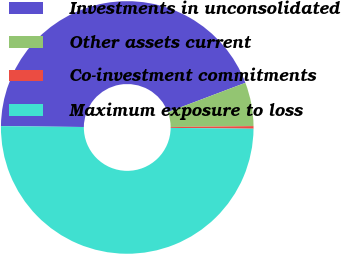Convert chart to OTSL. <chart><loc_0><loc_0><loc_500><loc_500><pie_chart><fcel>Investments in unconsolidated<fcel>Other assets current<fcel>Co-investment commitments<fcel>Maximum exposure to loss<nl><fcel>44.08%<fcel>5.58%<fcel>0.33%<fcel>50.0%<nl></chart> 